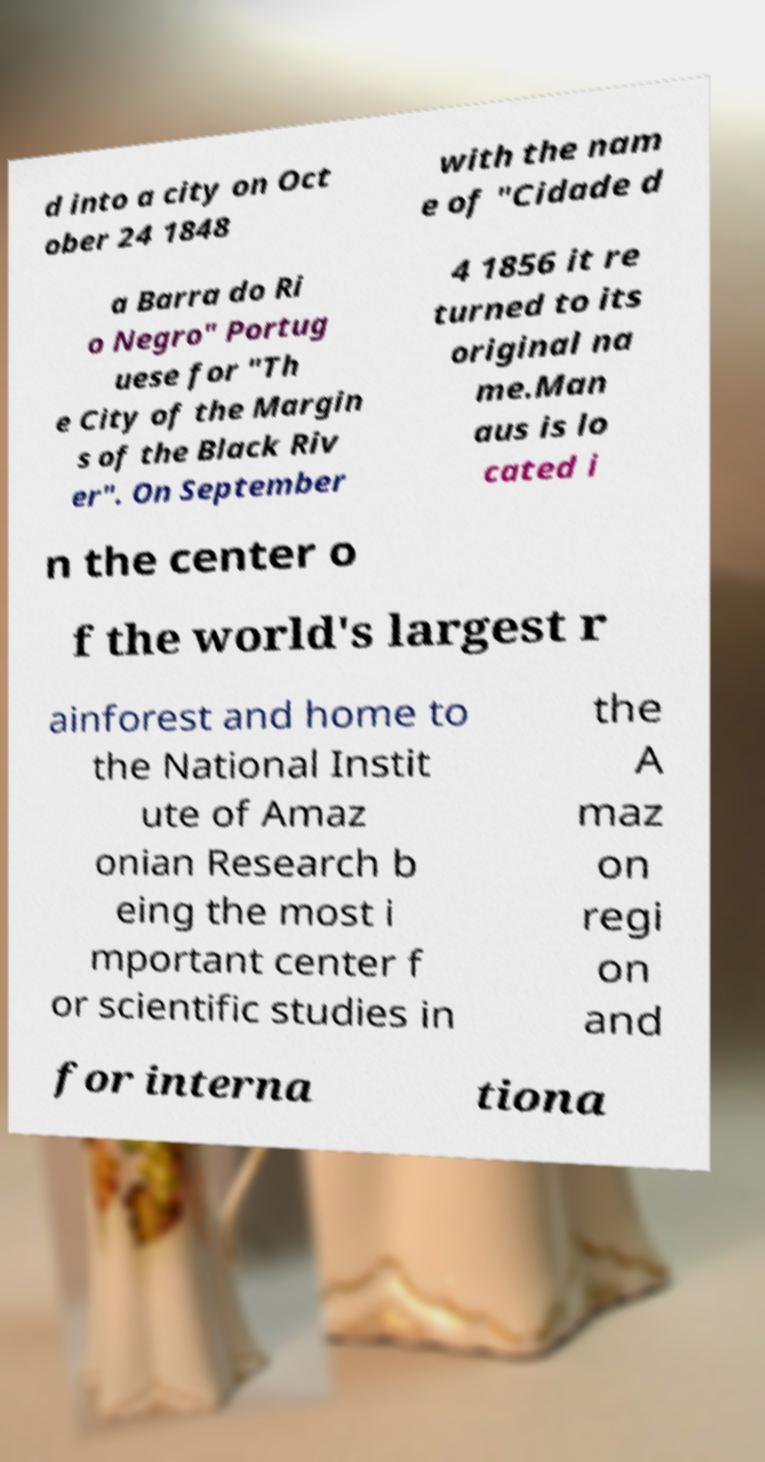Could you assist in decoding the text presented in this image and type it out clearly? d into a city on Oct ober 24 1848 with the nam e of "Cidade d a Barra do Ri o Negro" Portug uese for "Th e City of the Margin s of the Black Riv er". On September 4 1856 it re turned to its original na me.Man aus is lo cated i n the center o f the world's largest r ainforest and home to the National Instit ute of Amaz onian Research b eing the most i mportant center f or scientific studies in the A maz on regi on and for interna tiona 